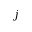Convert formula to latex. <formula><loc_0><loc_0><loc_500><loc_500>j</formula> 